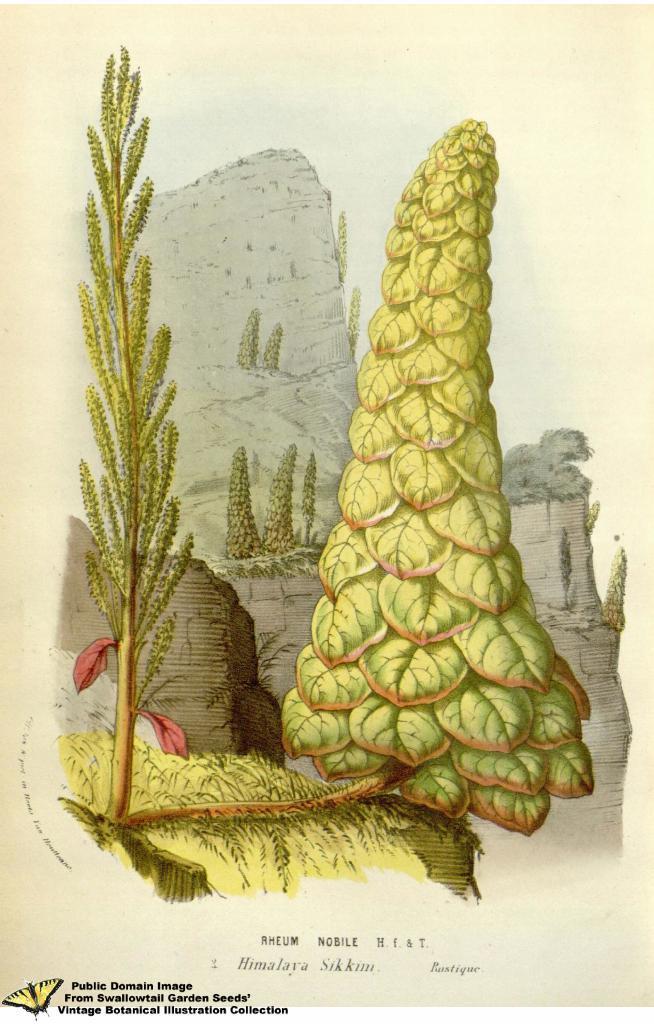In one or two sentences, can you explain what this image depicts? Here in this picture we can see an animated image, in which we can see plants, rocks and trees present all over there. 